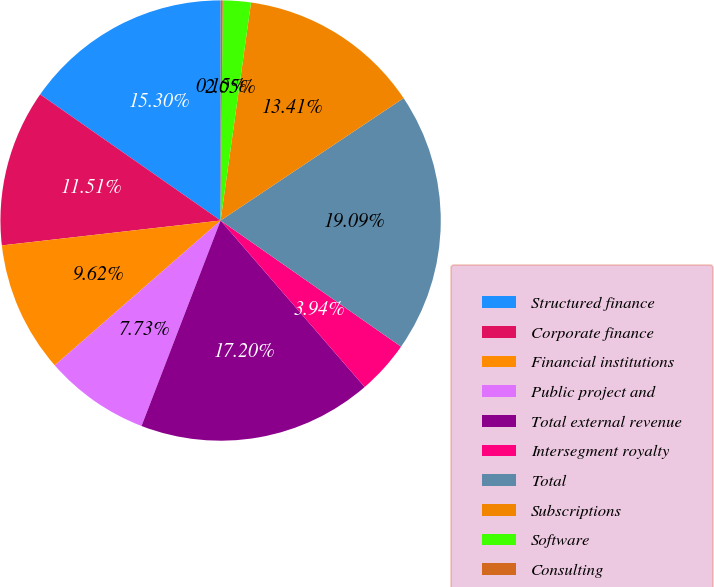<chart> <loc_0><loc_0><loc_500><loc_500><pie_chart><fcel>Structured finance<fcel>Corporate finance<fcel>Financial institutions<fcel>Public project and<fcel>Total external revenue<fcel>Intersegment royalty<fcel>Total<fcel>Subscriptions<fcel>Software<fcel>Consulting<nl><fcel>15.3%<fcel>11.51%<fcel>9.62%<fcel>7.73%<fcel>17.2%<fcel>3.94%<fcel>19.09%<fcel>13.41%<fcel>2.05%<fcel>0.15%<nl></chart> 